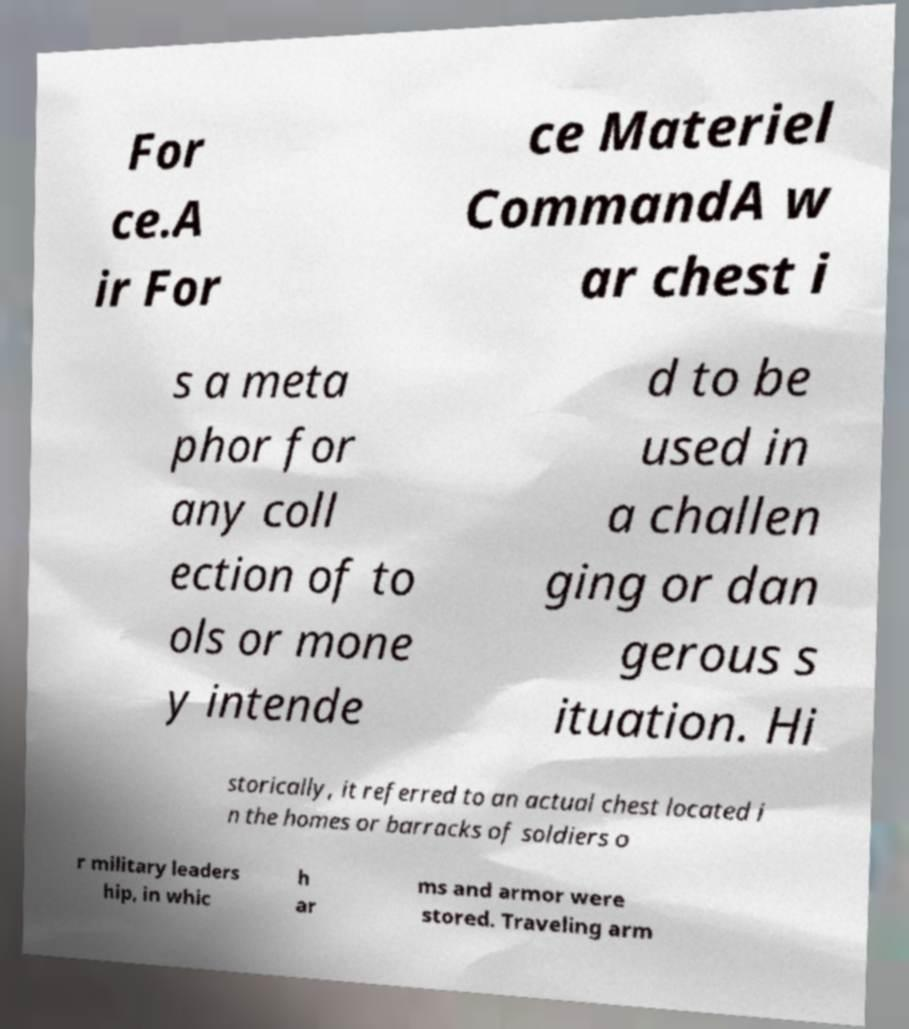Please read and relay the text visible in this image. What does it say? For ce.A ir For ce Materiel CommandA w ar chest i s a meta phor for any coll ection of to ols or mone y intende d to be used in a challen ging or dan gerous s ituation. Hi storically, it referred to an actual chest located i n the homes or barracks of soldiers o r military leaders hip, in whic h ar ms and armor were stored. Traveling arm 